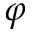<formula> <loc_0><loc_0><loc_500><loc_500>\varphi</formula> 